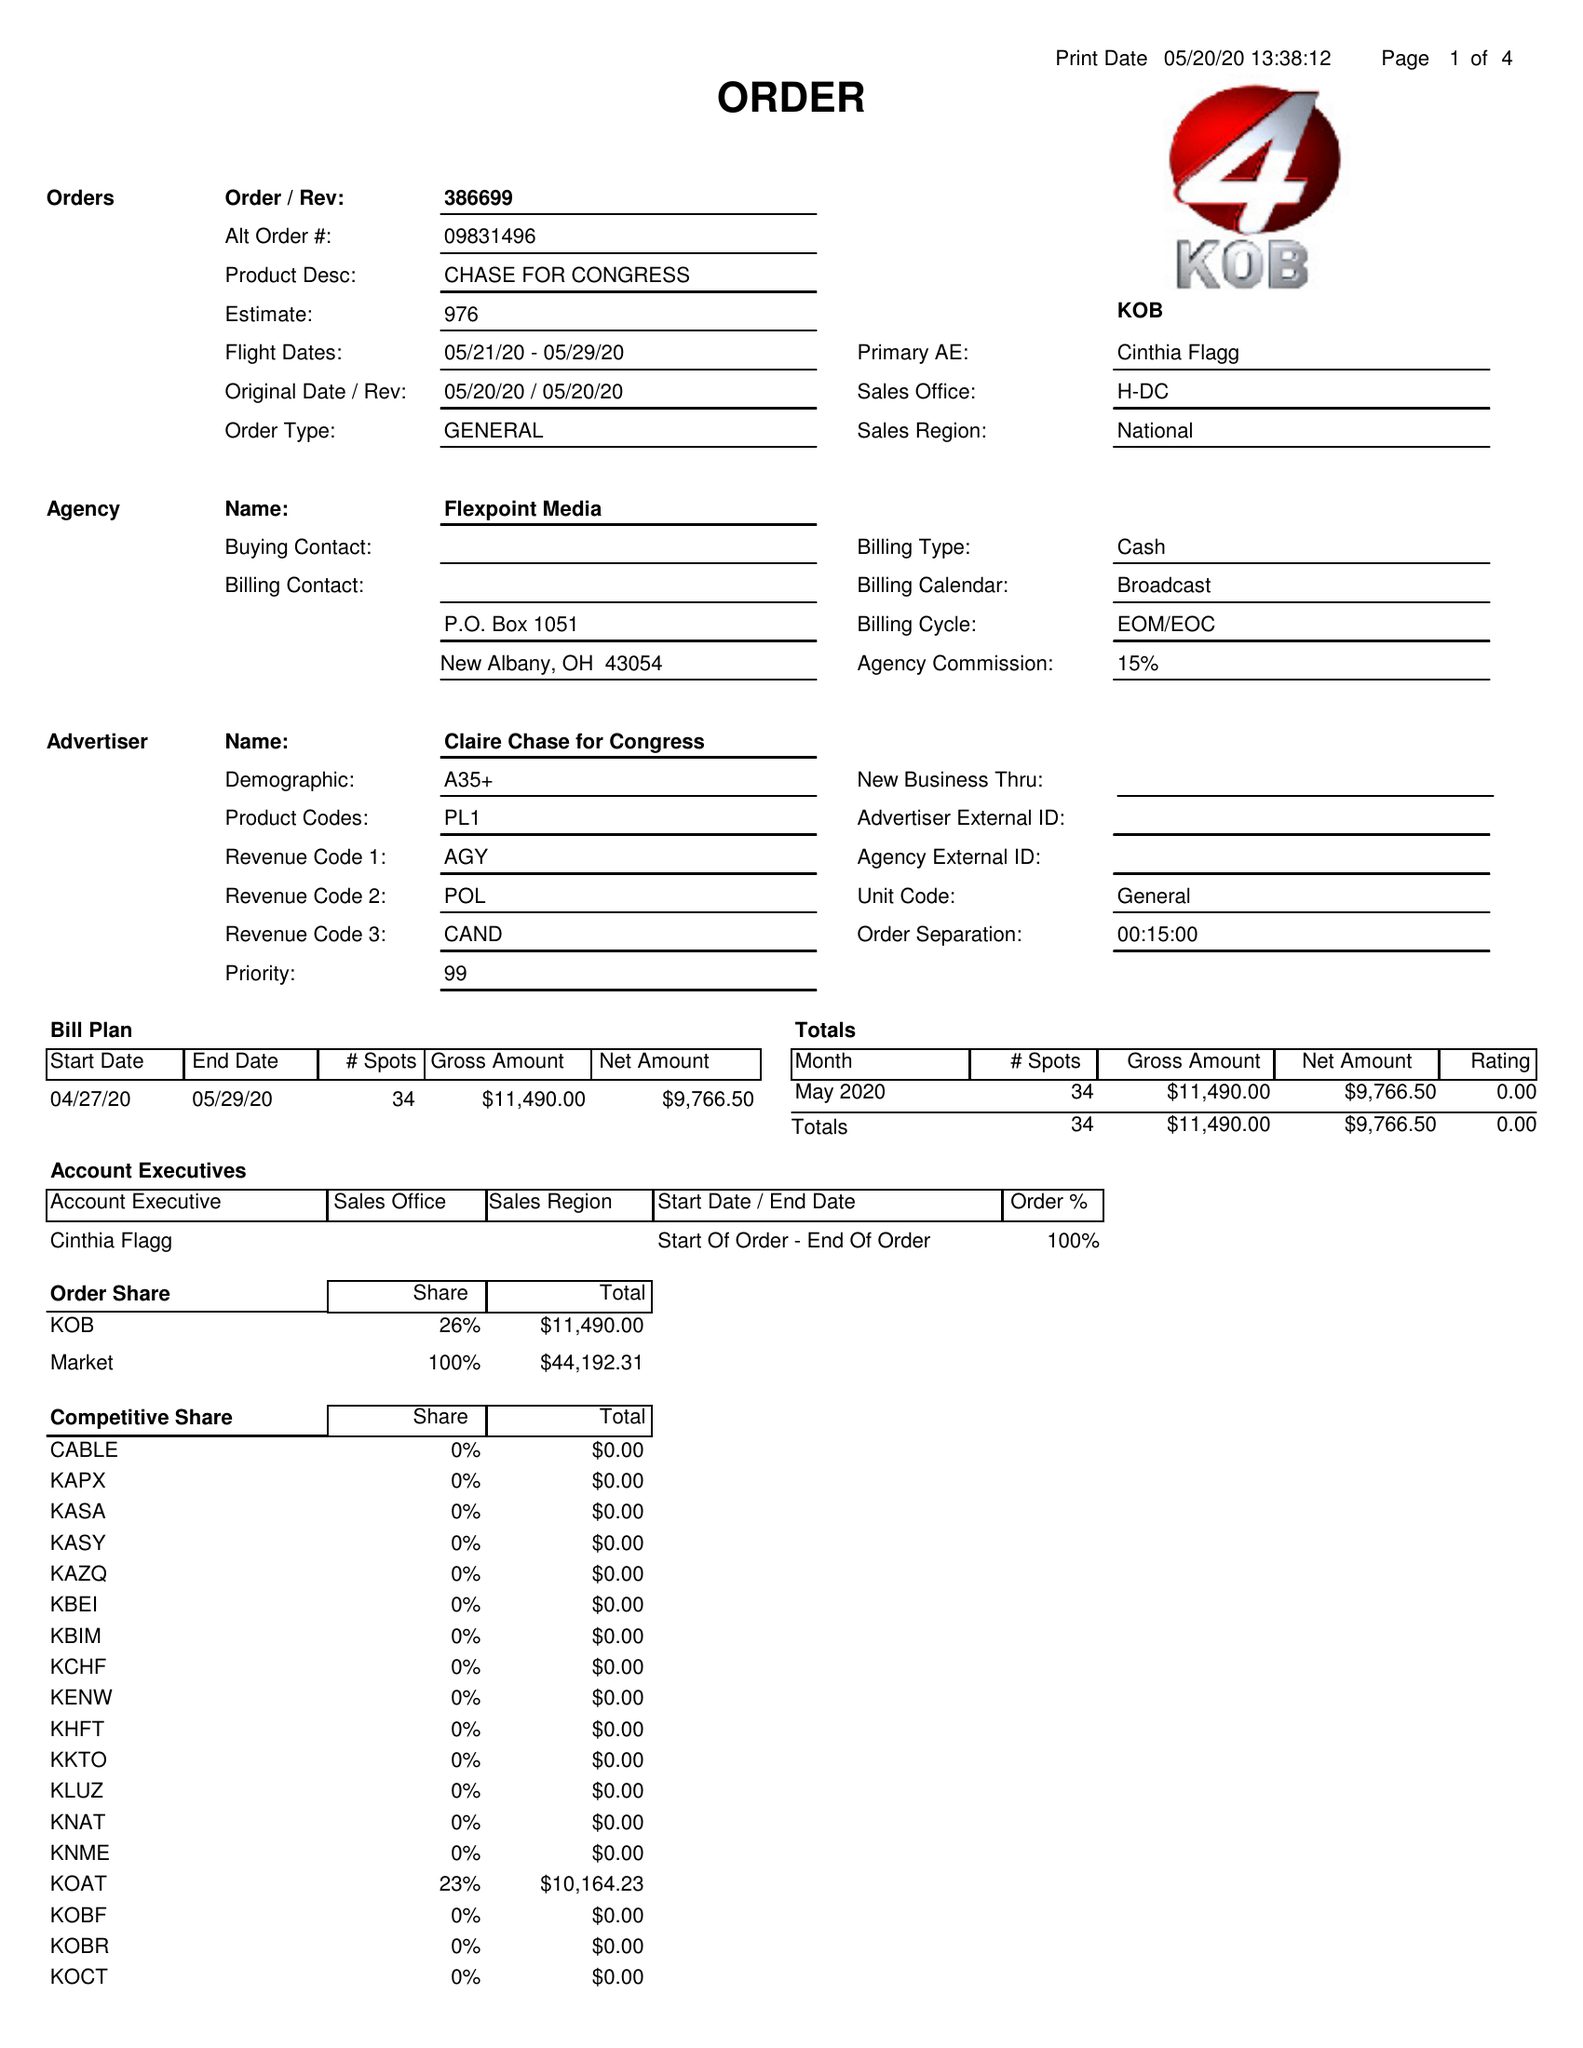What is the value for the advertiser?
Answer the question using a single word or phrase. CLAIRE CHASE FOR CONGRESS 